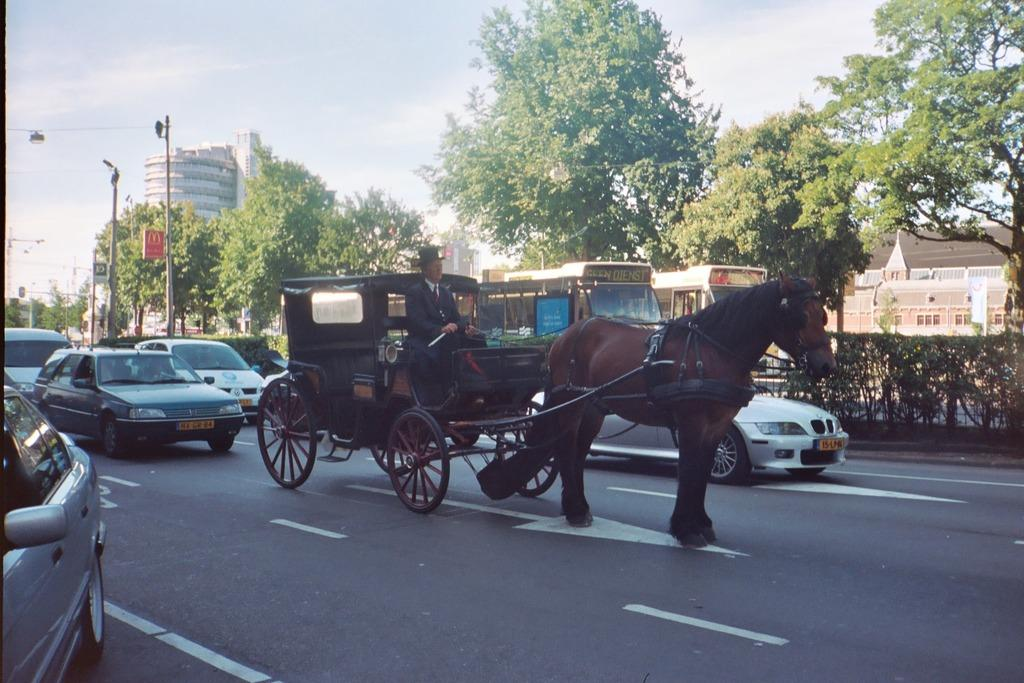What type of setting is depicted in the image? The image is an outside view. What can be seen in the foreground of the image? There is a cart in the image. What is happening on the road in the image? There are cars on the road in the image. What can be seen in the background of the image? There are trees, buildings, and poles in the background of the image. What is visible at the top of the image? The sky is visible at the top of the image. Can you tell me how many basketballs are being played with in the image? There are no basketballs present in the image. What is the cart being used for in the image? The image does not provide information about the purpose of the cart. 